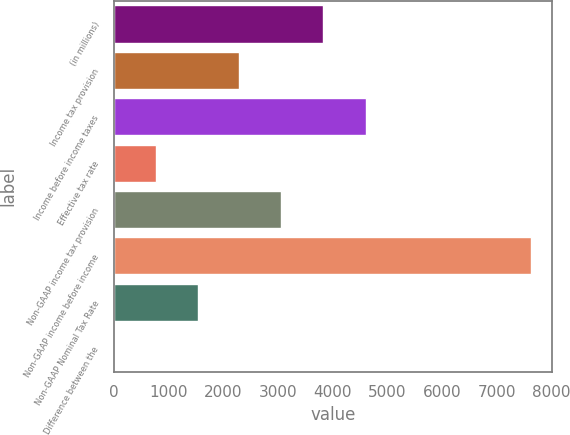Convert chart to OTSL. <chart><loc_0><loc_0><loc_500><loc_500><bar_chart><fcel>(in millions)<fcel>Income tax provision<fcel>Income before income taxes<fcel>Effective tax rate<fcel>Non-GAAP income tax provision<fcel>Non-GAAP income before income<fcel>Non-GAAP Nominal Tax Rate<fcel>Difference between the<nl><fcel>3813.3<fcel>2289.42<fcel>4602<fcel>765.54<fcel>3051.36<fcel>7623<fcel>1527.48<fcel>3.6<nl></chart> 